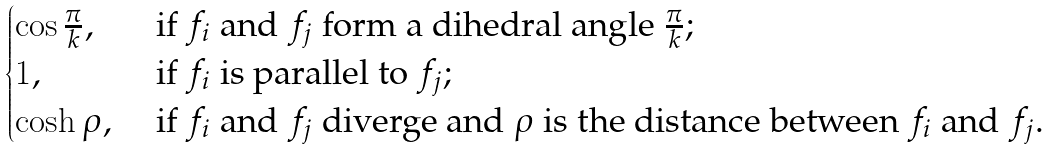Convert formula to latex. <formula><loc_0><loc_0><loc_500><loc_500>\begin{cases} \cos \frac { \pi } { k } , & \text { if $f_{i}$ and $f_{j}$ form a dihedral angle $\frac{\pi}{k}$;} \\ 1 , & \text { if $f_{i}$ is parallel to $f_{j}$;} \\ \cosh \rho , & \text { if $f_{i}$ and $f_{j}$ diverge and $\rho$ is the distance between $f_{i}$ and $f_{j}$.} \end{cases}</formula> 